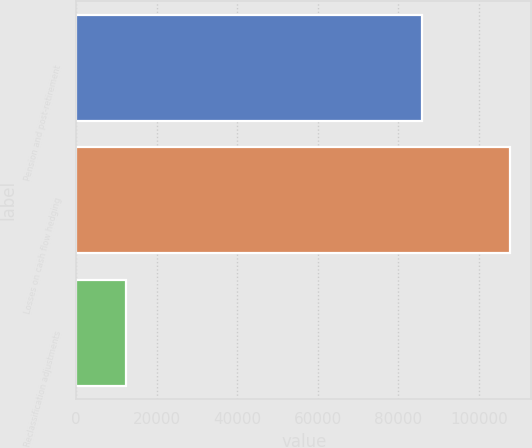Convert chart. <chart><loc_0><loc_0><loc_500><loc_500><bar_chart><fcel>Pension and post-retirement<fcel>Losses on cash flow hedging<fcel>Reclassification adjustments<nl><fcel>85823<fcel>107713<fcel>12515<nl></chart> 